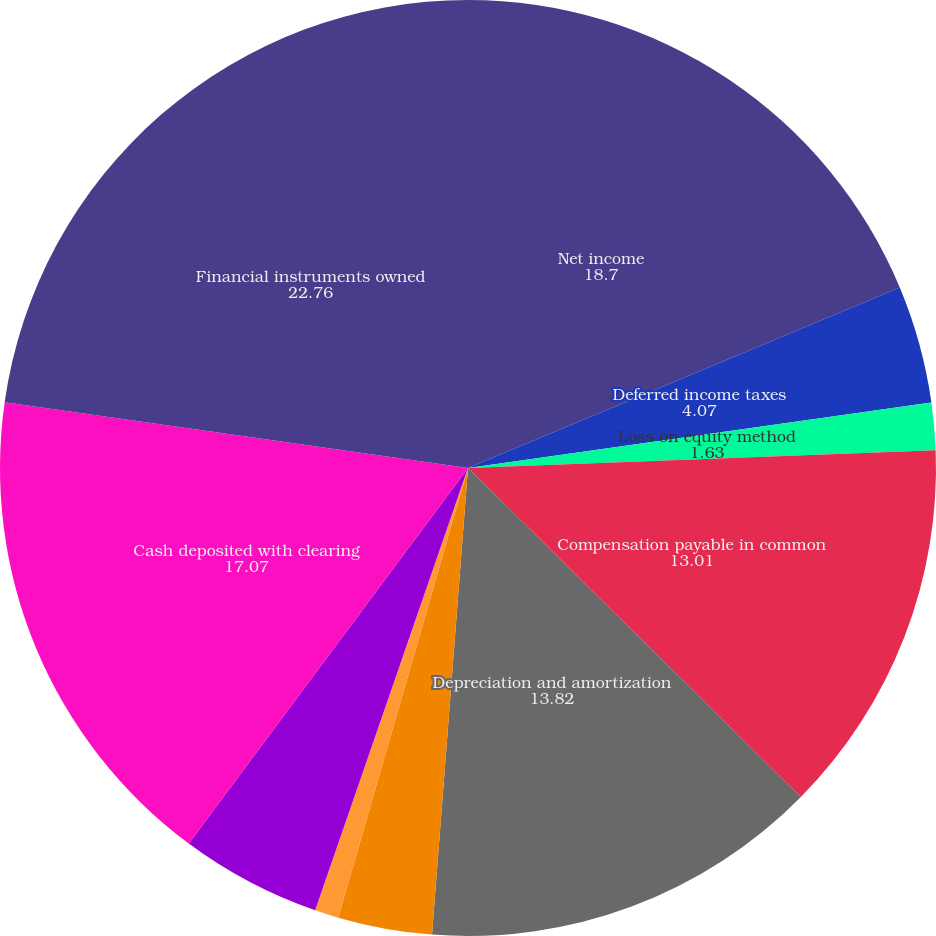<chart> <loc_0><loc_0><loc_500><loc_500><pie_chart><fcel>Net income<fcel>Deferred income taxes<fcel>Loss on equity method<fcel>Compensation payable in common<fcel>Depreciation and amortization<fcel>Gain on sale of securities<fcel>(Gain) loss on retirement of<fcel>Impairment charges and<fcel>Cash deposited with clearing<fcel>Financial instruments owned<nl><fcel>18.7%<fcel>4.07%<fcel>1.63%<fcel>13.01%<fcel>13.82%<fcel>3.25%<fcel>0.82%<fcel>4.88%<fcel>17.07%<fcel>22.76%<nl></chart> 